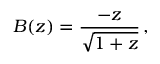Convert formula to latex. <formula><loc_0><loc_0><loc_500><loc_500>B ( z ) = { \frac { - z } { \sqrt { 1 + z } } } \, ,</formula> 